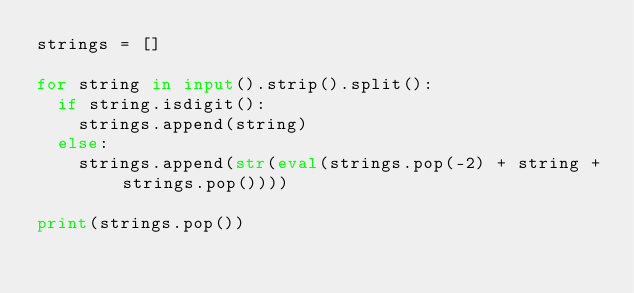<code> <loc_0><loc_0><loc_500><loc_500><_Python_>strings = []

for string in input().strip().split():
  if string.isdigit():
    strings.append(string)
  else:
    strings.append(str(eval(strings.pop(-2) + string + strings.pop())))

print(strings.pop())
</code> 